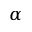Convert formula to latex. <formula><loc_0><loc_0><loc_500><loc_500>\alpha</formula> 